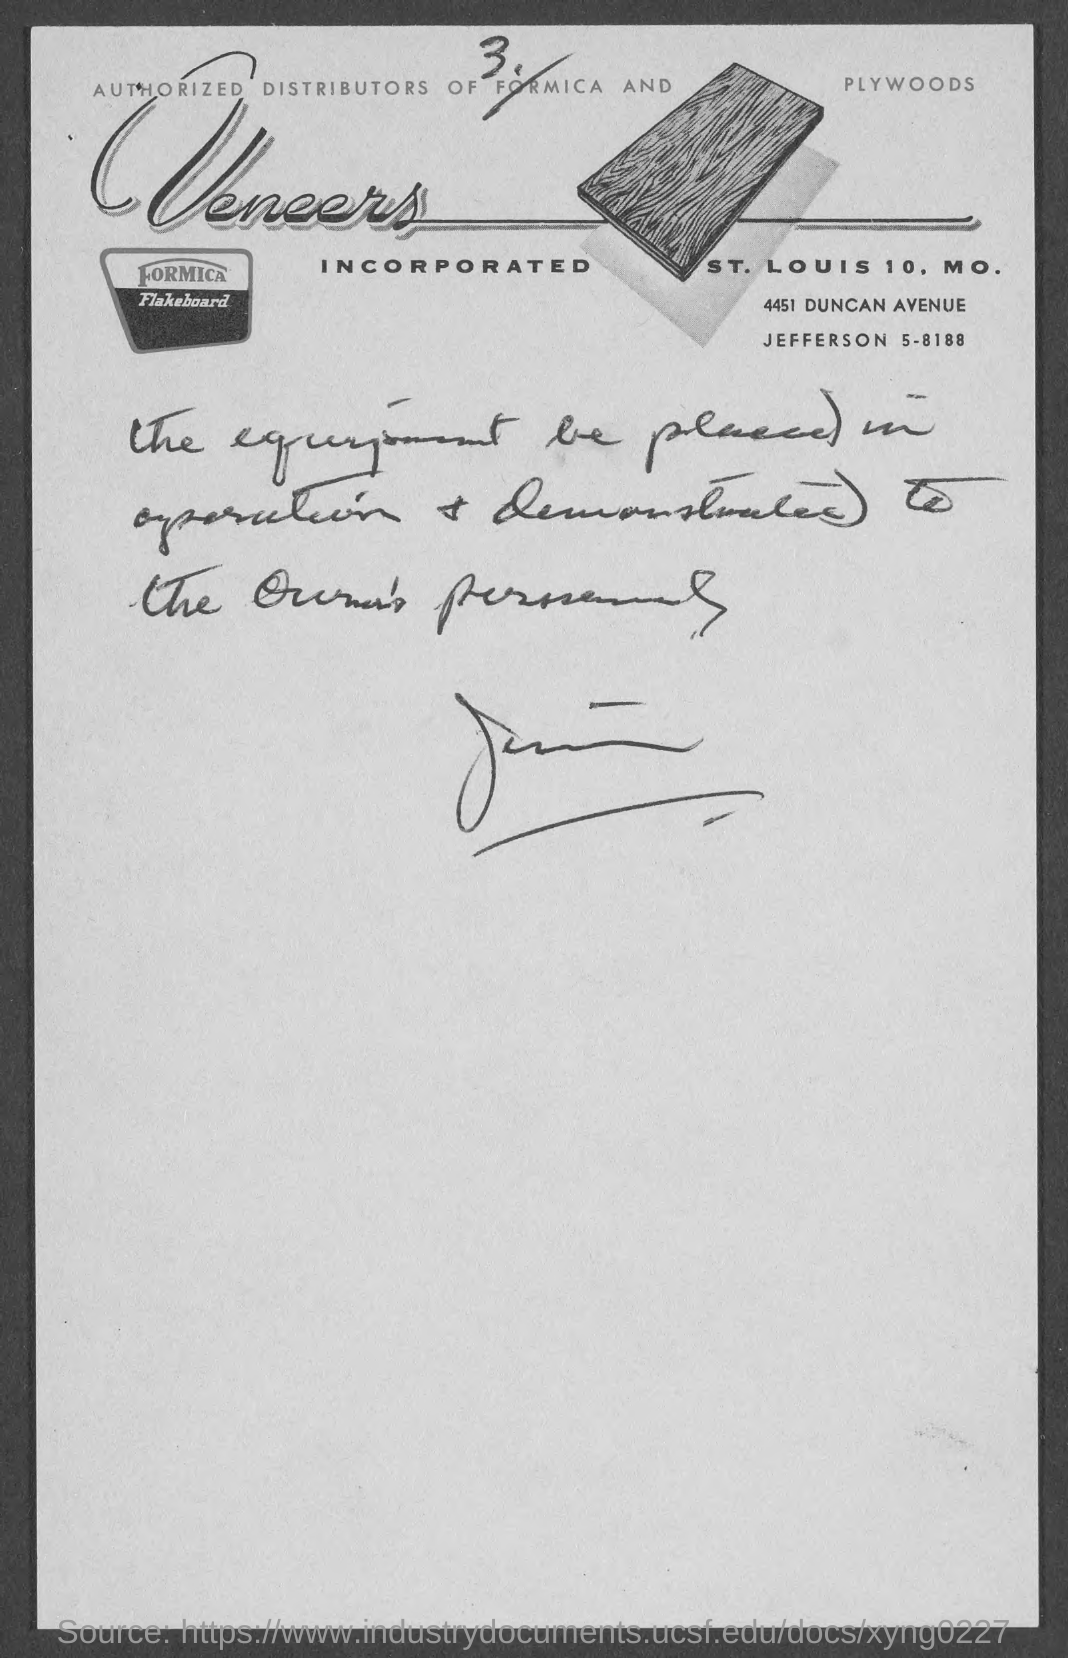Indicate a few pertinent items in this graphic. Formica and plywood distributors are authorized to sell these products. Veneers are also available through authorized distributors. 